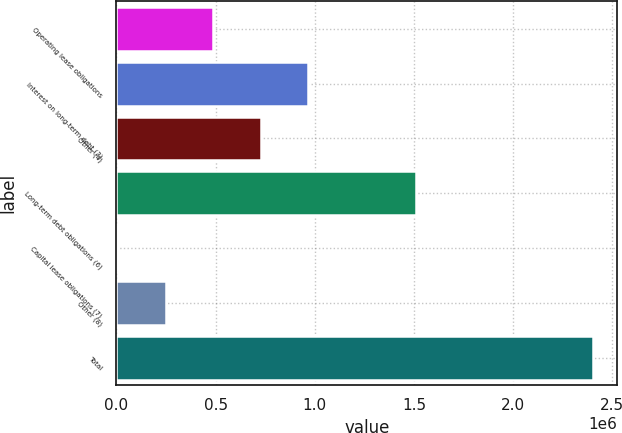Convert chart. <chart><loc_0><loc_0><loc_500><loc_500><bar_chart><fcel>Operating lease obligations<fcel>Interest on long-term debt (3)<fcel>Other (4)<fcel>Long-term debt obligations (6)<fcel>Capital lease obligations (7)<fcel>Other (8)<fcel>Total<nl><fcel>488429<fcel>967321<fcel>727875<fcel>1.50994e+06<fcel>9538<fcel>248984<fcel>2.404e+06<nl></chart> 